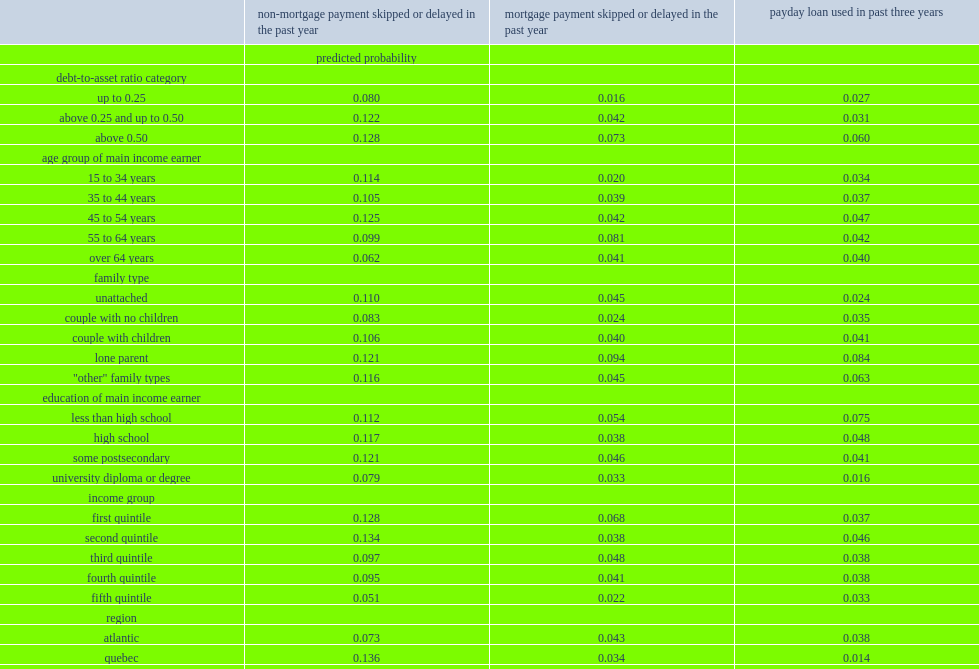By what percentage would families with a debt-to-asset ratio above 0.5 miss a non-mortagage payment? 0.128. By what percentage would families with a debt-to-asset ratio above 0.25 and up to 0.50 miss a non-mortagage payment? 0.122. By what percentage would families with a debt-to-asset ratio equal to or below 0.25 miss a non-mortagage payment? 0.08. By what percentage would families owned their principal residence without mortgage miss a non-mortgage payment? 0.078. By what percentage would families who did not own their principal residence miss a non-mortgage payment? 0.14. By what percentage would families in the lowest income quintile skip or delay a non-mortgage payment? 0.128. By what percentage would families in the fourth income quintile skip or delay a non-mortgage payment? 0.095. By what percentage would families in the fifth income quintile skip or delay a non-mortgage payment? 0.051. By what percentage would families where the major income earner was aged 65 or over miss non-mortgage payment? 0.062. By what percentage would families where the major income earner was aged 45 to 54 miss non-mortgage payment? 0.125. Which kind of income earner were less likely to miss non-mortgage payments, university degree holders or high school diploma holders? University diploma or degree. By what percentage would families in quebec skip or delay non-mortgage payment? 0.136. By what percentage would families in ontario skip or delay non-mortgage payment? 0.096. By what percentage would those in the lowest debt-to-asset ratio skip or delay a mortgage payment? 0.016. By what percentage would those with debt-to-asset ratios above 0.50 skip or delay a mortgage payment? 0.073. Which family type had a higher probability of missing a mortgage payment, lone-parent families or couples without children? Lone parent. Among all age groups of main income earner, which group was most likely to miss a mortgage payment? 55 to 64 years. Which age group of main income earner was less likely to miss a mortgage payment, families where the major income earner was 15 to 34 years old or families where the major income earner was 45 to 54 years old? 15 to 34 years. Which income group had a lower probability of missing a mortgage payment, families in the top income quintile (the fifth) or families in the bottom income quintile(the first)? Fifth quintile. Regionally, which group of families were more likely to miss mortgage payment, families in the prairies or families in ontario? Prairies. Can you give me this table as a dict? {'header': ['', 'non-mortgage payment skipped or delayed in the past year', 'mortgage payment skipped or delayed in the past year', 'payday loan used in past three years'], 'rows': [['', 'predicted probability', '', ''], ['debt-to-asset ratio category', '', '', ''], ['up to 0.25', '0.080', '0.016', '0.027'], ['above 0.25 and up to 0.50', '0.122', '0.042', '0.031'], ['above 0.50', '0.128', '0.073', '0.060'], ['age group of main income earner', '', '', ''], ['15 to 34 years', '0.114', '0.020', '0.034'], ['35 to 44 years', '0.105', '0.039', '0.037'], ['45 to 54 years', '0.125', '0.042', '0.047'], ['55 to 64 years', '0.099', '0.081', '0.042'], ['over 64 years', '0.062', '0.041', '0.040'], ['family type', '', '', ''], ['unattached', '0.110', '0.045', '0.024'], ['couple with no children', '0.083', '0.024', '0.035'], ['couple with children', '0.106', '0.040', '0.041'], ['lone parent', '0.121', '0.094', '0.084'], ['"other" family types', '0.116', '0.045', '0.063'], ['education of main income earner', '', '', ''], ['less than high school', '0.112', '0.054', '0.075'], ['high school', '0.117', '0.038', '0.048'], ['some postsecondary', '0.121', '0.046', '0.041'], ['university diploma or degree', '0.079', '0.033', '0.016'], ['income group', '', '', ''], ['first quintile', '0.128', '0.068', '0.037'], ['second quintile', '0.134', '0.038', '0.046'], ['third quintile', '0.097', '0.048', '0.038'], ['fourth quintile', '0.095', '0.041', '0.038'], ['fifth quintile', '0.051', '0.022', '0.033'], ['region', '', '', ''], ['atlantic', '0.073', '0.043', '0.038'], ['quebec', '0.136', '0.034', '0.014'], ['ontario', '0.096', '0.032', '0.046'], ['prairies', '0.106', '0.068', '0.056'], ['british columbia', '0.091', '0.039', '0.044'], ['sex of main income earner', '', '', ''], ['male', '0.107', '0.042', '0.040'], ['female', '0.103', '0.038', '0.037'], ['home ownership status', '', '', ''], ['own without mortgage', '0.078', '..', '0.017'], ['own with mortgage', '0.085', '..', '0.019'], ['do not own', '0.140', '..', '0.082']]} 